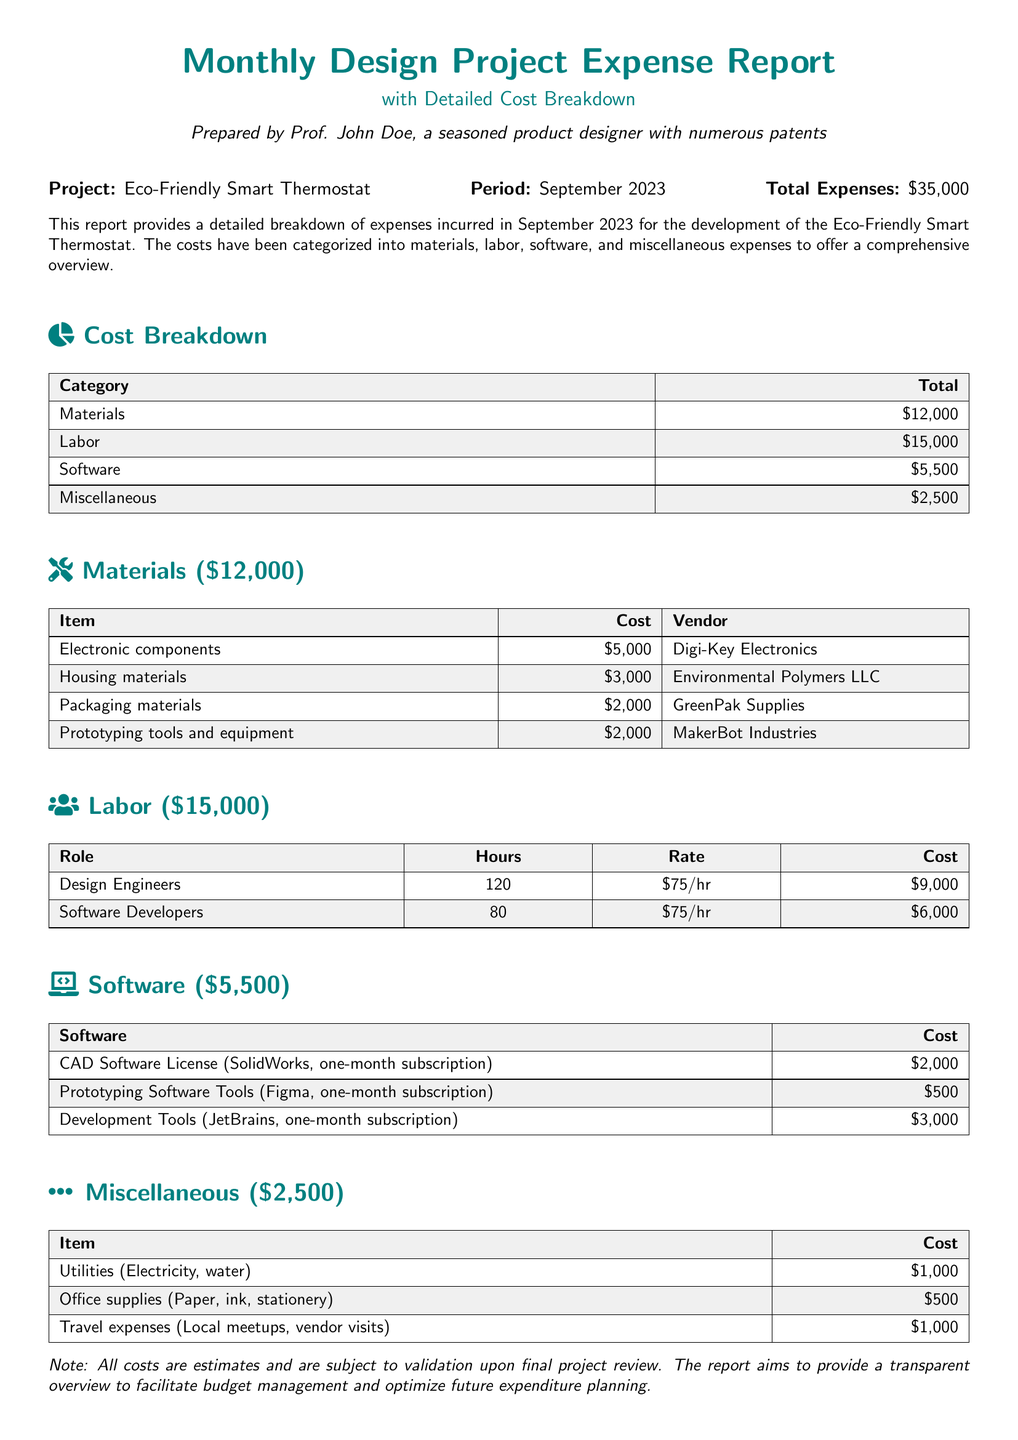What is the project name? The project name is mentioned at the beginning of the report under "Project:".
Answer: Eco-Friendly Smart Thermostat What is the period for this expense report? The period is stated next to "Period:" in the report.
Answer: September 2023 What is the total expense amount? The total expenses are reported in the section that mentions "Total Expenses:".
Answer: $35,000 How much was spent on labor? The labor costs are detailed in the cost breakdown section.
Answer: $15,000 What is the cost of electronic components? The cost for electronic components is listed under the materials section.
Answer: $5,000 Which company provided housing materials? The vendor for housing materials is mentioned in the materials section.
Answer: Environmental Polymers LLC What is the total cost for software? The total software costs are detailed in the cost breakdown section.
Answer: $5,500 How many hours of design engineering labor were incurred? The hours worked by design engineers are noted in the labor section.
Answer: 120 What category has the highest expense? The category with the highest expense can be inferred from the total expenses breakdown.
Answer: Labor 